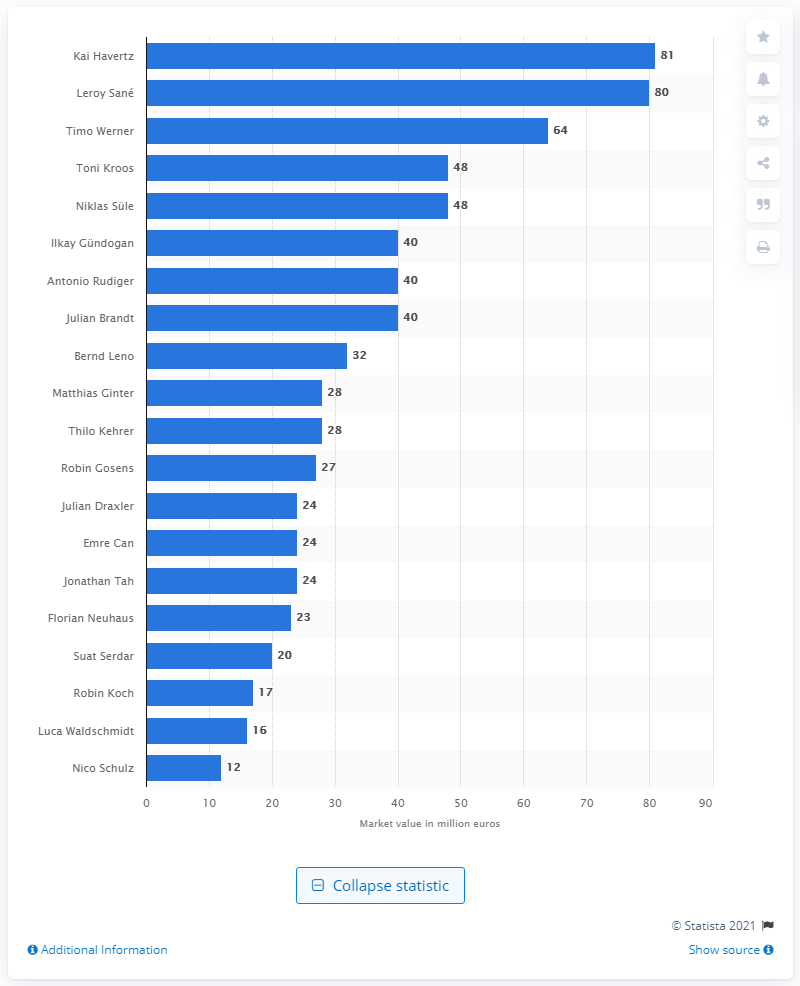Outline some significant characteristics in this image. Kai Havertz's value is 81... The most valuable football player in Germany is Kai Havertz. 